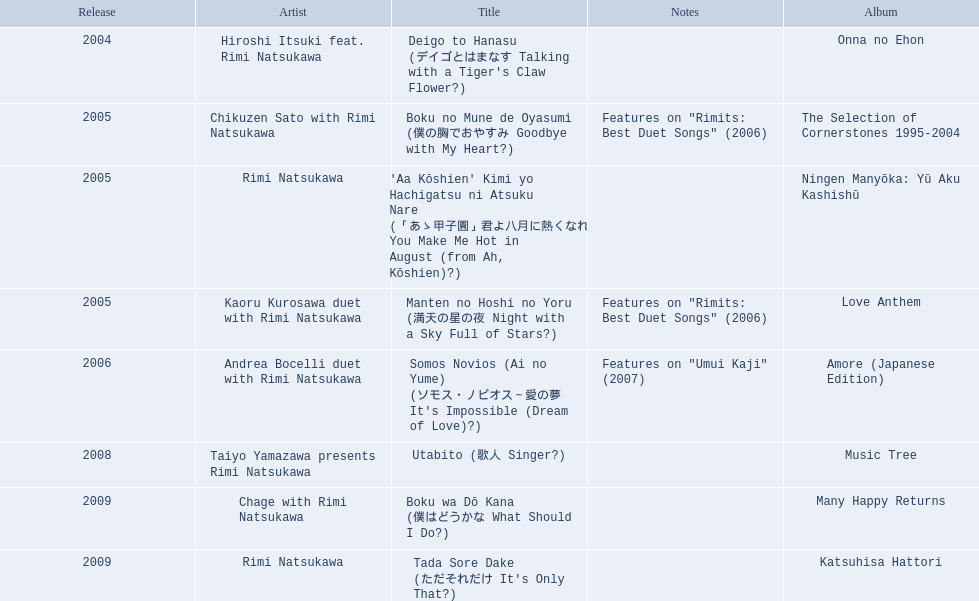What are the complete list of titles? Deigo to Hanasu (デイゴとはまなす Talking with a Tiger's Claw Flower?), Boku no Mune de Oyasumi (僕の胸でおやすみ Goodbye with My Heart?), 'Aa Kōshien' Kimi yo Hachigatsu ni Atsuku Nare (「あゝ甲子園」君よ八月に熱くなれ You Make Me Hot in August (from Ah, Kōshien)?), Manten no Hoshi no Yoru (満天の星の夜 Night with a Sky Full of Stars?), Somos Novios (Ai no Yume) (ソモス・ノビオス～愛の夢 It's Impossible (Dream of Love)?), Utabito (歌人 Singer?), Boku wa Dō Kana (僕はどうかな What Should I Do?), Tada Sore Dake (ただそれだけ It's Only That?). What are their notations? , Features on "Rimits: Best Duet Songs" (2006), , Features on "Rimits: Best Duet Songs" (2006), Features on "Umui Kaji" (2007), , , . Which title has the same notations as "manten no hoshi no yoru" (man tian noxing noye night with a sky full of stars)? Boku no Mune de Oyasumi (僕の胸でおやすみ Goodbye with My Heart?). When was the release date of onna no ehon? 2004. When was the selection of cornerstones 1995-2004 launched? 2005. What was launched in 2008? Music Tree. 